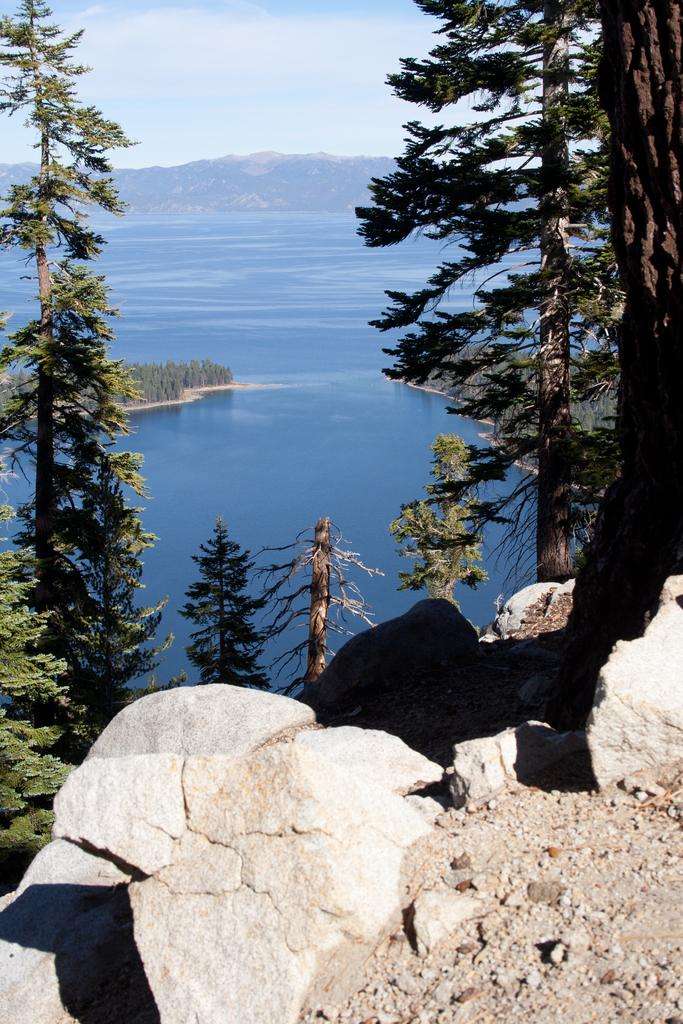What is located at the bottom of the image? There are stones at the bottom of the image. What can be seen in the background of the image? There are mountains and water in the background of the image. What is visible in the sky in the image? The sky is visible in the background of the image. What type of vegetation is in the foreground of the image? There are trees in the foreground of the image. What type of railway is depicted in the image? There is no railway present in the image. Is the image a work of fiction or non-fiction? The image itself is neither fiction nor non-fiction; it is a photograph or illustration. Can you see a toy in the image? There is no toy present in the image. 